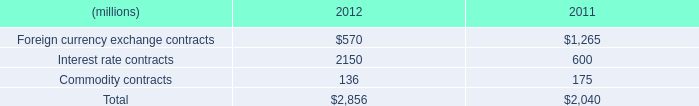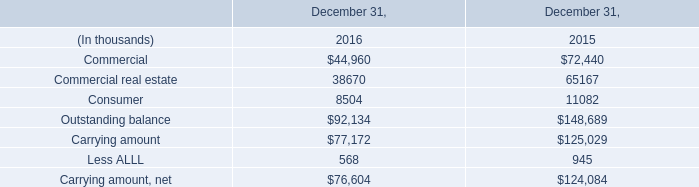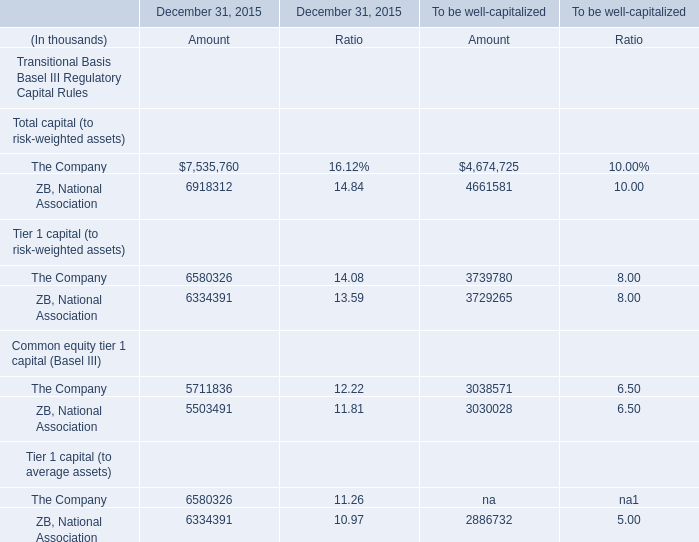What is the sum of Amount in the range of 5000000 and 6000000 in 2015 for December 31, 2015? (in thousand) 
Computations: (5711836 + 5503491)
Answer: 11215327.0. 